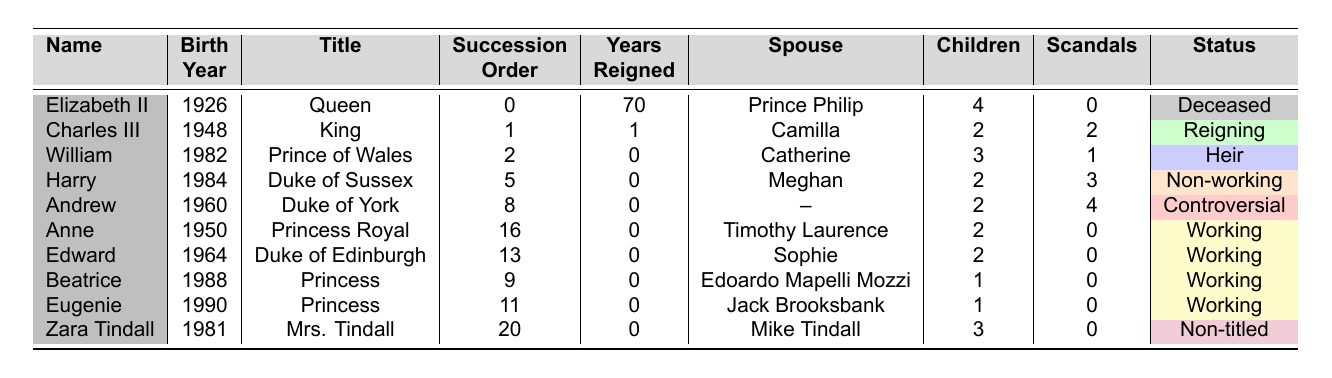What is the birth year of Charles III? The table shows that Charles III was born in 1948.
Answer: 1948 How many children does Elizabeth II have? According to the table, Elizabeth II has 4 children listed.
Answer: 4 Who has more scandals, Andrew or Harry? The table indicates that Andrew has 4 scandals and Harry has 3. Thus, Andrew has more scandals.
Answer: Andrew What is the total number of children among the royal family members listed? By summing the children of each member: 4 (Elizabeth) + 2 (Charles) + 3 (William) + 2 (Harry) + 2 (Andrew) + 2 (Anne) + 2 (Edward) + 1 (Beatrice) + 1 (Eugenie) + 3 (Zara) = 22.
Answer: 22 Is it true that Anne has no scandals? The table shows that Anne has 0 scandals, confirming it is true.
Answer: Yes Which royal family member has reigned the longest and for how many years? According to the table, Elizabeth II has reigned for 70 years, the longest compared to others.
Answer: Elizabeth II, 70 years What is the average number of scandals for the working royal members? The working royals are Anne, Edward, Beatrice, Eugenie, and Zara. Their scandals count: 0, 0, 0, 0, 0. The average is (0 + 0 + 0 + 0 + 0) / 5 = 0.
Answer: 0 Who is the heir apparent to the throne? The table lists William as the Prince of Wales, indicating he is the heir apparent to the throne.
Answer: William Which royal family members are currently working royals? The working royals are Anne, Edward, Beatrice, Eugenie, and Zara, as indicated by their status in the table.
Answer: Anne, Edward, Beatrice, Eugenie, Zara If we exclude the deceased members, how many royal family members are still alive? Counting the members with no death year listed: Charles III, William, Harry, Andrew, Anne, Edward, Beatrice, Eugenie, and Zara gives us a total of 9.
Answer: 9 